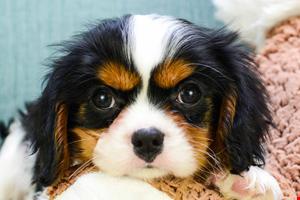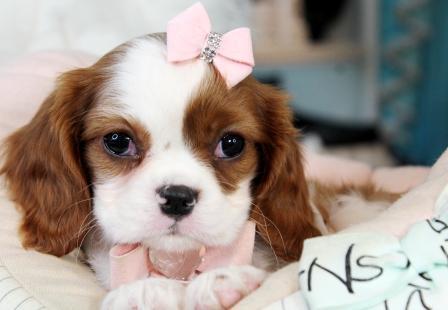The first image is the image on the left, the second image is the image on the right. For the images displayed, is the sentence "The right image shows a row of four young dogs." factually correct? Answer yes or no. No. The first image is the image on the left, the second image is the image on the right. Analyze the images presented: Is the assertion "The right image contains more dogs than the left image." valid? Answer yes or no. No. 